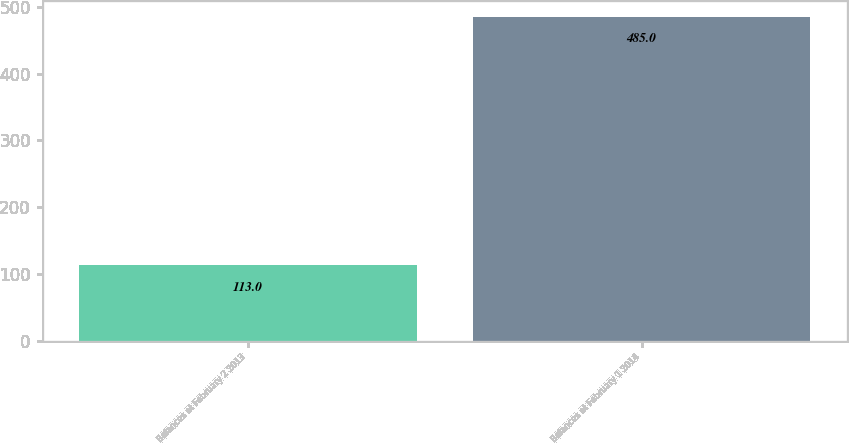Convert chart to OTSL. <chart><loc_0><loc_0><loc_500><loc_500><bar_chart><fcel>Balances at February 2 2013<fcel>Balances at February 1 2014<nl><fcel>113<fcel>485<nl></chart> 